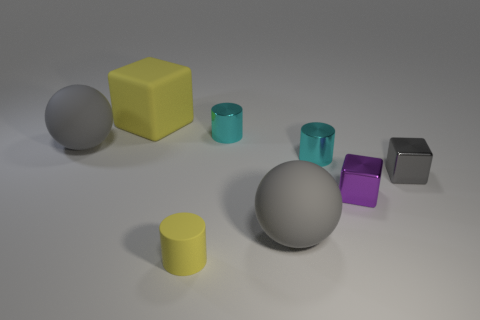Does the big thing on the left side of the large yellow cube have the same shape as the yellow rubber thing on the left side of the rubber cylinder?
Your answer should be compact. No. Are there any large cubes that have the same color as the small matte cylinder?
Ensure brevity in your answer.  Yes. There is a purple shiny object; how many objects are to the right of it?
Your response must be concise. 1. What material is the gray thing that is both left of the purple object and to the right of the yellow block?
Provide a succinct answer. Rubber. How many other blocks have the same size as the purple block?
Make the answer very short. 1. What is the color of the metal object behind the sphere that is to the left of the rubber block?
Ensure brevity in your answer.  Cyan. Is there a small brown matte object?
Keep it short and to the point. No. Does the purple metallic object have the same shape as the gray shiny object?
Give a very brief answer. Yes. The matte object that is the same color as the large rubber cube is what size?
Your answer should be compact. Small. What number of yellow blocks are behind the big gray rubber object that is left of the yellow cube?
Give a very brief answer. 1. 